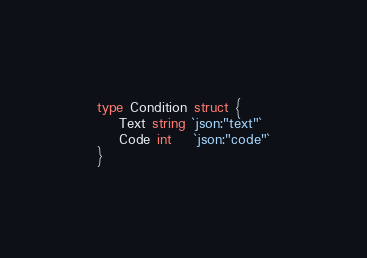Convert code to text. <code><loc_0><loc_0><loc_500><loc_500><_Go_>type Condition struct {
	Text string `json:"text"`
	Code int    `json:"code"`
}
</code> 